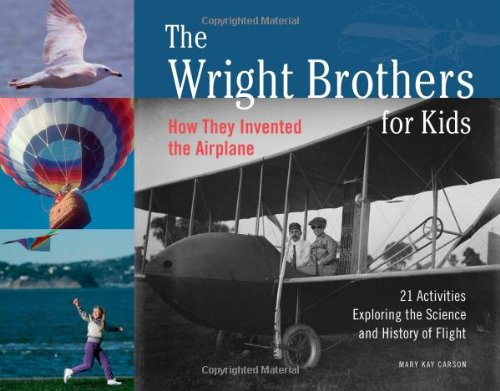What is the genre of this book? This book falls under the genre of Children's Books, specifically designed to educate children on historical and scientific topics through engaging narratives and activities. 